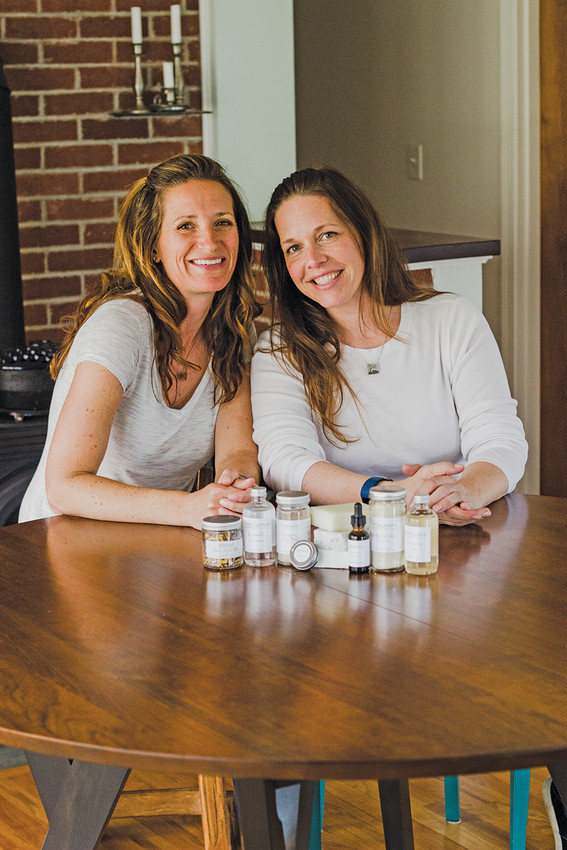What kind of products are these two individuals showcasing, and who might their target audience be? The products displayed on the table appear to be various skincare or wellness items, possibly including lotions, oils, and other bottled products. The target audience for these items could be individuals interested in natural or artisan skincare solutions. Given the friendly and trustworthy demeanor of the two individuals, they may also appeal to a market looking for products made and endorsed by real people with a passion for quality and wellness. What could be the story behind their product line, and how would they communicate this to potential customers? The story behind their product line might involve a shared journey of discovering a need for reliable, natural beauty solutions. Perhaps they were inspired by their own skincare challenges or a desire to create products free of harsh chemicals. To communicate their story, they could share personal anecdotes, detailing their experiences and the process of creating their products. They could use social media, blogging, or even video content to reach and engage with their audience. Their approach would emphasize authenticity, quality, and the personal touch behind each product. 